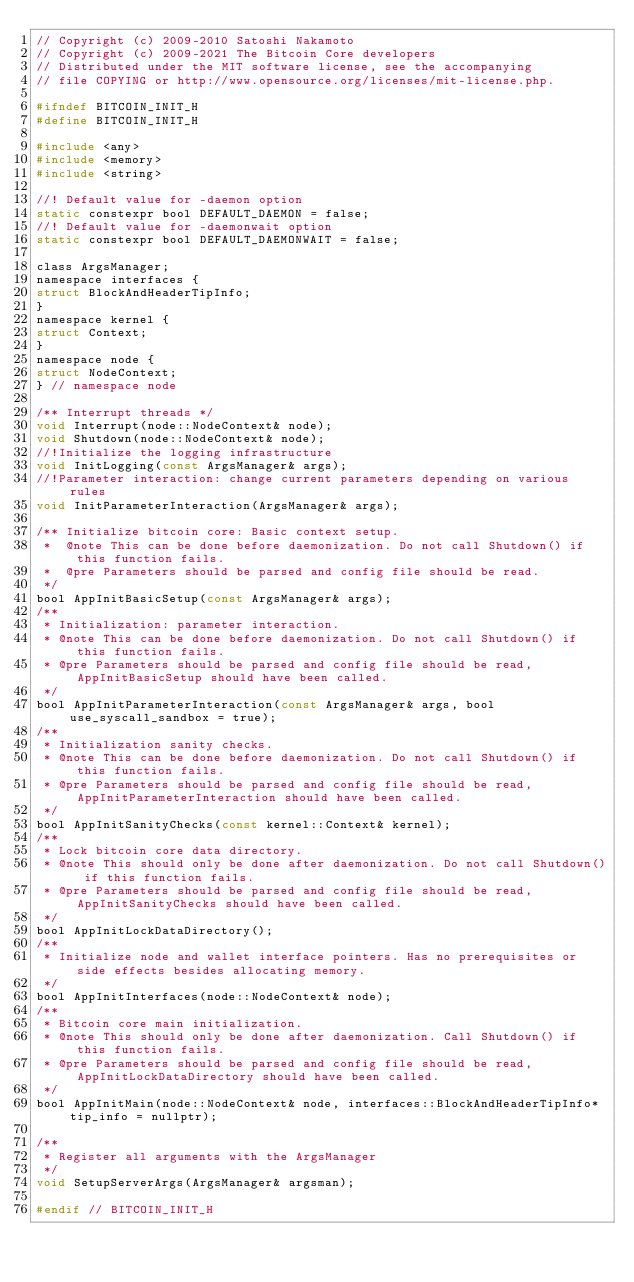<code> <loc_0><loc_0><loc_500><loc_500><_C_>// Copyright (c) 2009-2010 Satoshi Nakamoto
// Copyright (c) 2009-2021 The Bitcoin Core developers
// Distributed under the MIT software license, see the accompanying
// file COPYING or http://www.opensource.org/licenses/mit-license.php.

#ifndef BITCOIN_INIT_H
#define BITCOIN_INIT_H

#include <any>
#include <memory>
#include <string>

//! Default value for -daemon option
static constexpr bool DEFAULT_DAEMON = false;
//! Default value for -daemonwait option
static constexpr bool DEFAULT_DAEMONWAIT = false;

class ArgsManager;
namespace interfaces {
struct BlockAndHeaderTipInfo;
}
namespace kernel {
struct Context;
}
namespace node {
struct NodeContext;
} // namespace node

/** Interrupt threads */
void Interrupt(node::NodeContext& node);
void Shutdown(node::NodeContext& node);
//!Initialize the logging infrastructure
void InitLogging(const ArgsManager& args);
//!Parameter interaction: change current parameters depending on various rules
void InitParameterInteraction(ArgsManager& args);

/** Initialize bitcoin core: Basic context setup.
 *  @note This can be done before daemonization. Do not call Shutdown() if this function fails.
 *  @pre Parameters should be parsed and config file should be read.
 */
bool AppInitBasicSetup(const ArgsManager& args);
/**
 * Initialization: parameter interaction.
 * @note This can be done before daemonization. Do not call Shutdown() if this function fails.
 * @pre Parameters should be parsed and config file should be read, AppInitBasicSetup should have been called.
 */
bool AppInitParameterInteraction(const ArgsManager& args, bool use_syscall_sandbox = true);
/**
 * Initialization sanity checks.
 * @note This can be done before daemonization. Do not call Shutdown() if this function fails.
 * @pre Parameters should be parsed and config file should be read, AppInitParameterInteraction should have been called.
 */
bool AppInitSanityChecks(const kernel::Context& kernel);
/**
 * Lock bitcoin core data directory.
 * @note This should only be done after daemonization. Do not call Shutdown() if this function fails.
 * @pre Parameters should be parsed and config file should be read, AppInitSanityChecks should have been called.
 */
bool AppInitLockDataDirectory();
/**
 * Initialize node and wallet interface pointers. Has no prerequisites or side effects besides allocating memory.
 */
bool AppInitInterfaces(node::NodeContext& node);
/**
 * Bitcoin core main initialization.
 * @note This should only be done after daemonization. Call Shutdown() if this function fails.
 * @pre Parameters should be parsed and config file should be read, AppInitLockDataDirectory should have been called.
 */
bool AppInitMain(node::NodeContext& node, interfaces::BlockAndHeaderTipInfo* tip_info = nullptr);

/**
 * Register all arguments with the ArgsManager
 */
void SetupServerArgs(ArgsManager& argsman);

#endif // BITCOIN_INIT_H
</code> 